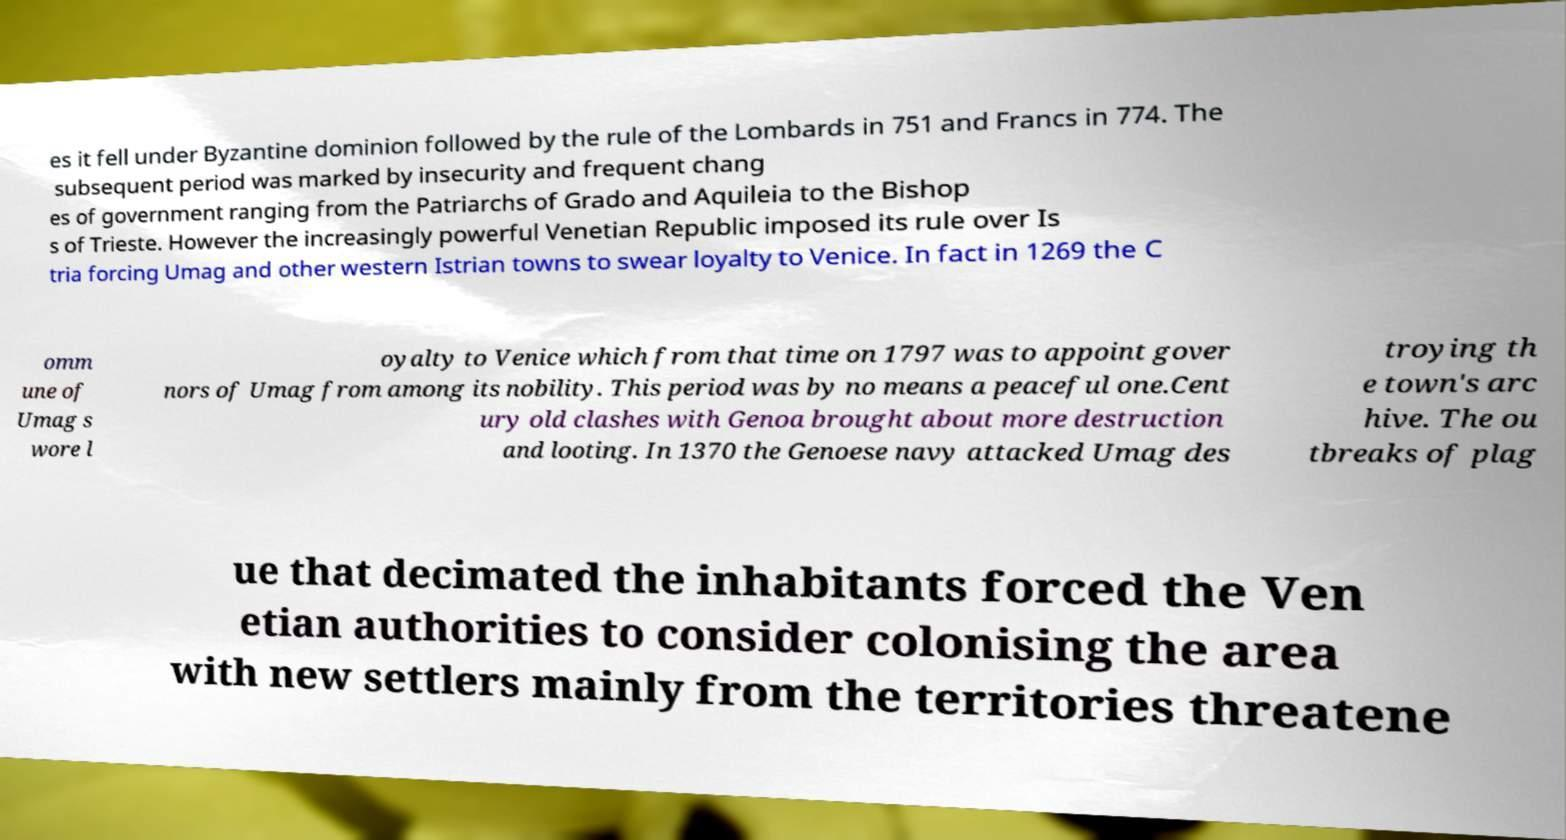What messages or text are displayed in this image? I need them in a readable, typed format. es it fell under Byzantine dominion followed by the rule of the Lombards in 751 and Francs in 774. The subsequent period was marked by insecurity and frequent chang es of government ranging from the Patriarchs of Grado and Aquileia to the Bishop s of Trieste. However the increasingly powerful Venetian Republic imposed its rule over Is tria forcing Umag and other western Istrian towns to swear loyalty to Venice. In fact in 1269 the C omm une of Umag s wore l oyalty to Venice which from that time on 1797 was to appoint gover nors of Umag from among its nobility. This period was by no means a peaceful one.Cent ury old clashes with Genoa brought about more destruction and looting. In 1370 the Genoese navy attacked Umag des troying th e town's arc hive. The ou tbreaks of plag ue that decimated the inhabitants forced the Ven etian authorities to consider colonising the area with new settlers mainly from the territories threatene 